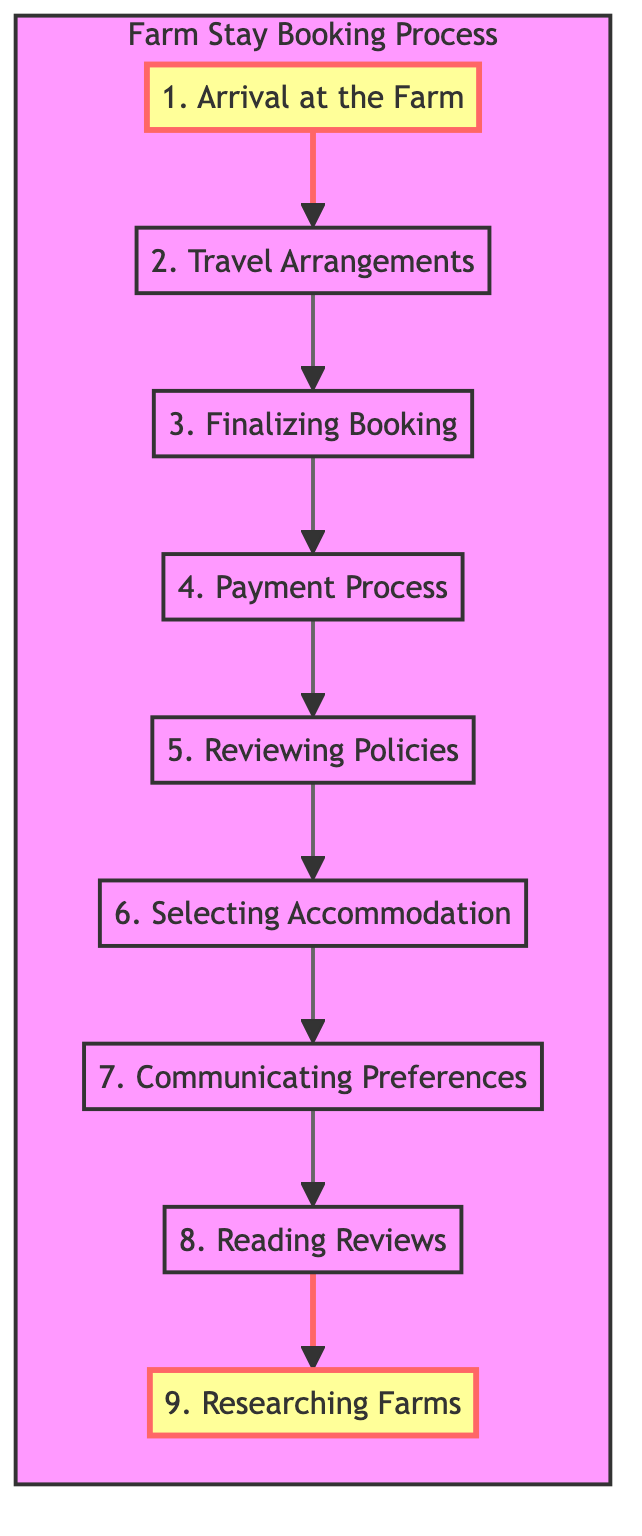What is the first step after arriving at the farm? The first step after arriving at the farm, as indicated in the diagram, is to check in at Green Meadows Farm, where guests receive a welcome package and farm map.
Answer: Check-in at Green Meadows Farm, receive a welcome package and farm map Which node comes before "Payment Process"? In the flow chart, "Payment Process" is preceded by "Finalizing Booking". This means that completing the finalizing of your booking occurs before making any payments.
Answer: Finalizing Booking How many total steps are depicted in the chart? The chart shows a total of nine steps in the booking process, starting from "Researching Farms" and ending with "Arrival at the Farm".
Answer: 9 What must you do after selecting accommodation? After selecting accommodation, the next step is to communicate preferences, which involves informing the farm owner of dietary restrictions and activity preferences via email.
Answer: Communicating Preferences What should you do before confirming your booking details? Before confirming your booking details, you should read the cancellation and refund policies. This step is crucial to ensure that you are aware of the terms before proceeding with the confirmation.
Answer: Reviewing Policies In what order do the steps flow? The steps flow in a sequence starting from "Researching Farms" at the bottom, moving up through "Reading Reviews", "Communicating Preferences", and so on, until reaching "Arrival at the Farm" at the top. This bottom-up flow illustrates the progression through the booking process.
Answer: Bottom to up Which step involves looking up reviews? The step that involves looking up reviews occurs after communicating preferences and before selecting accommodation, as denoted in the flow chart. It helps in making informed decisions based on feedback from previous visitors.
Answer: Reading Reviews What is the last step shown in the diagram? The last step shown in the flow chart is "Arrival at the Farm", which emphasizes that all previous actions culminate in this final experience of reaching the farm.
Answer: Arrival at the Farm 